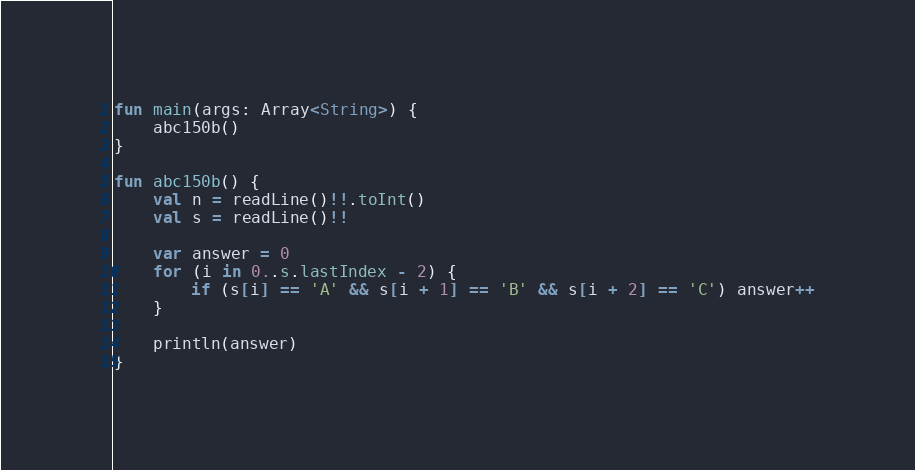<code> <loc_0><loc_0><loc_500><loc_500><_Kotlin_>fun main(args: Array<String>) {
    abc150b()
}

fun abc150b() {
    val n = readLine()!!.toInt()
    val s = readLine()!!

    var answer = 0
    for (i in 0..s.lastIndex - 2) {
        if (s[i] == 'A' && s[i + 1] == 'B' && s[i + 2] == 'C') answer++
    }

    println(answer)
}
</code> 